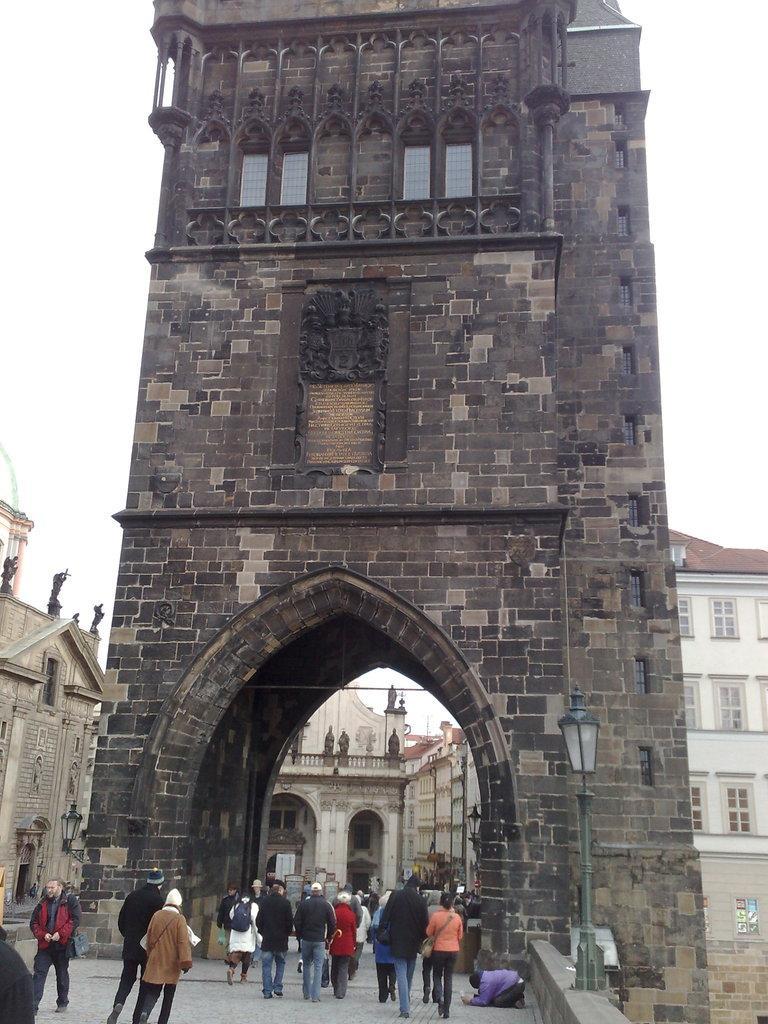How would you summarize this image in a sentence or two? This image consists of some buildings in the middle. There are some persons walking at the bottom. There is light on the right side. There is sky at the top. 